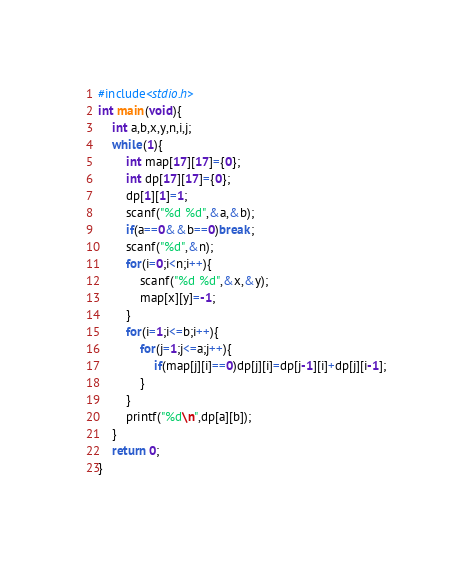<code> <loc_0><loc_0><loc_500><loc_500><_C_>#include<stdio.h>
int main(void){
    int a,b,x,y,n,i,j;
    while(1){
        int map[17][17]={0};
        int dp[17][17]={0};
        dp[1][1]=1;
        scanf("%d %d",&a,&b);
        if(a==0&&b==0)break;
        scanf("%d",&n);
        for(i=0;i<n;i++){
            scanf("%d %d",&x,&y);
            map[x][y]=-1;
        }
        for(i=1;i<=b;i++){
            for(j=1;j<=a;j++){
                if(map[j][i]==0)dp[j][i]=dp[j-1][i]+dp[j][i-1];
            }
        }
        printf("%d\n",dp[a][b]);
    }
    return 0;
}</code> 